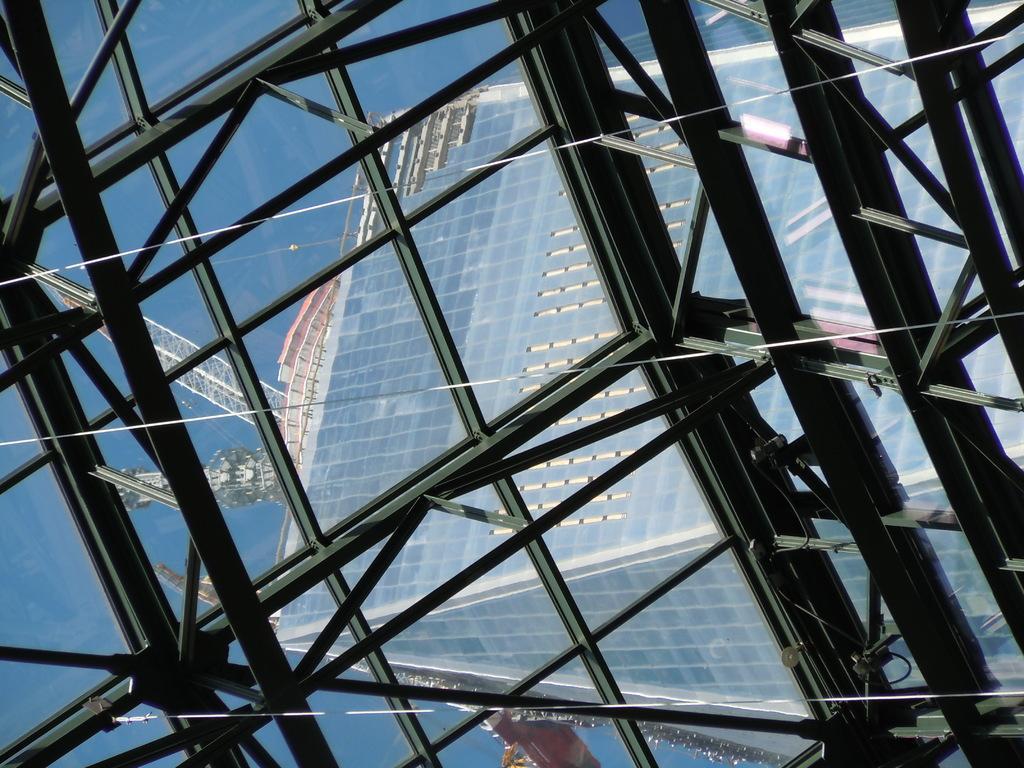In one or two sentences, can you explain what this image depicts? In the picture we can see a glass structure to it, we can see, full of iron rods and from the glass we can see another glass structure and a sky. 